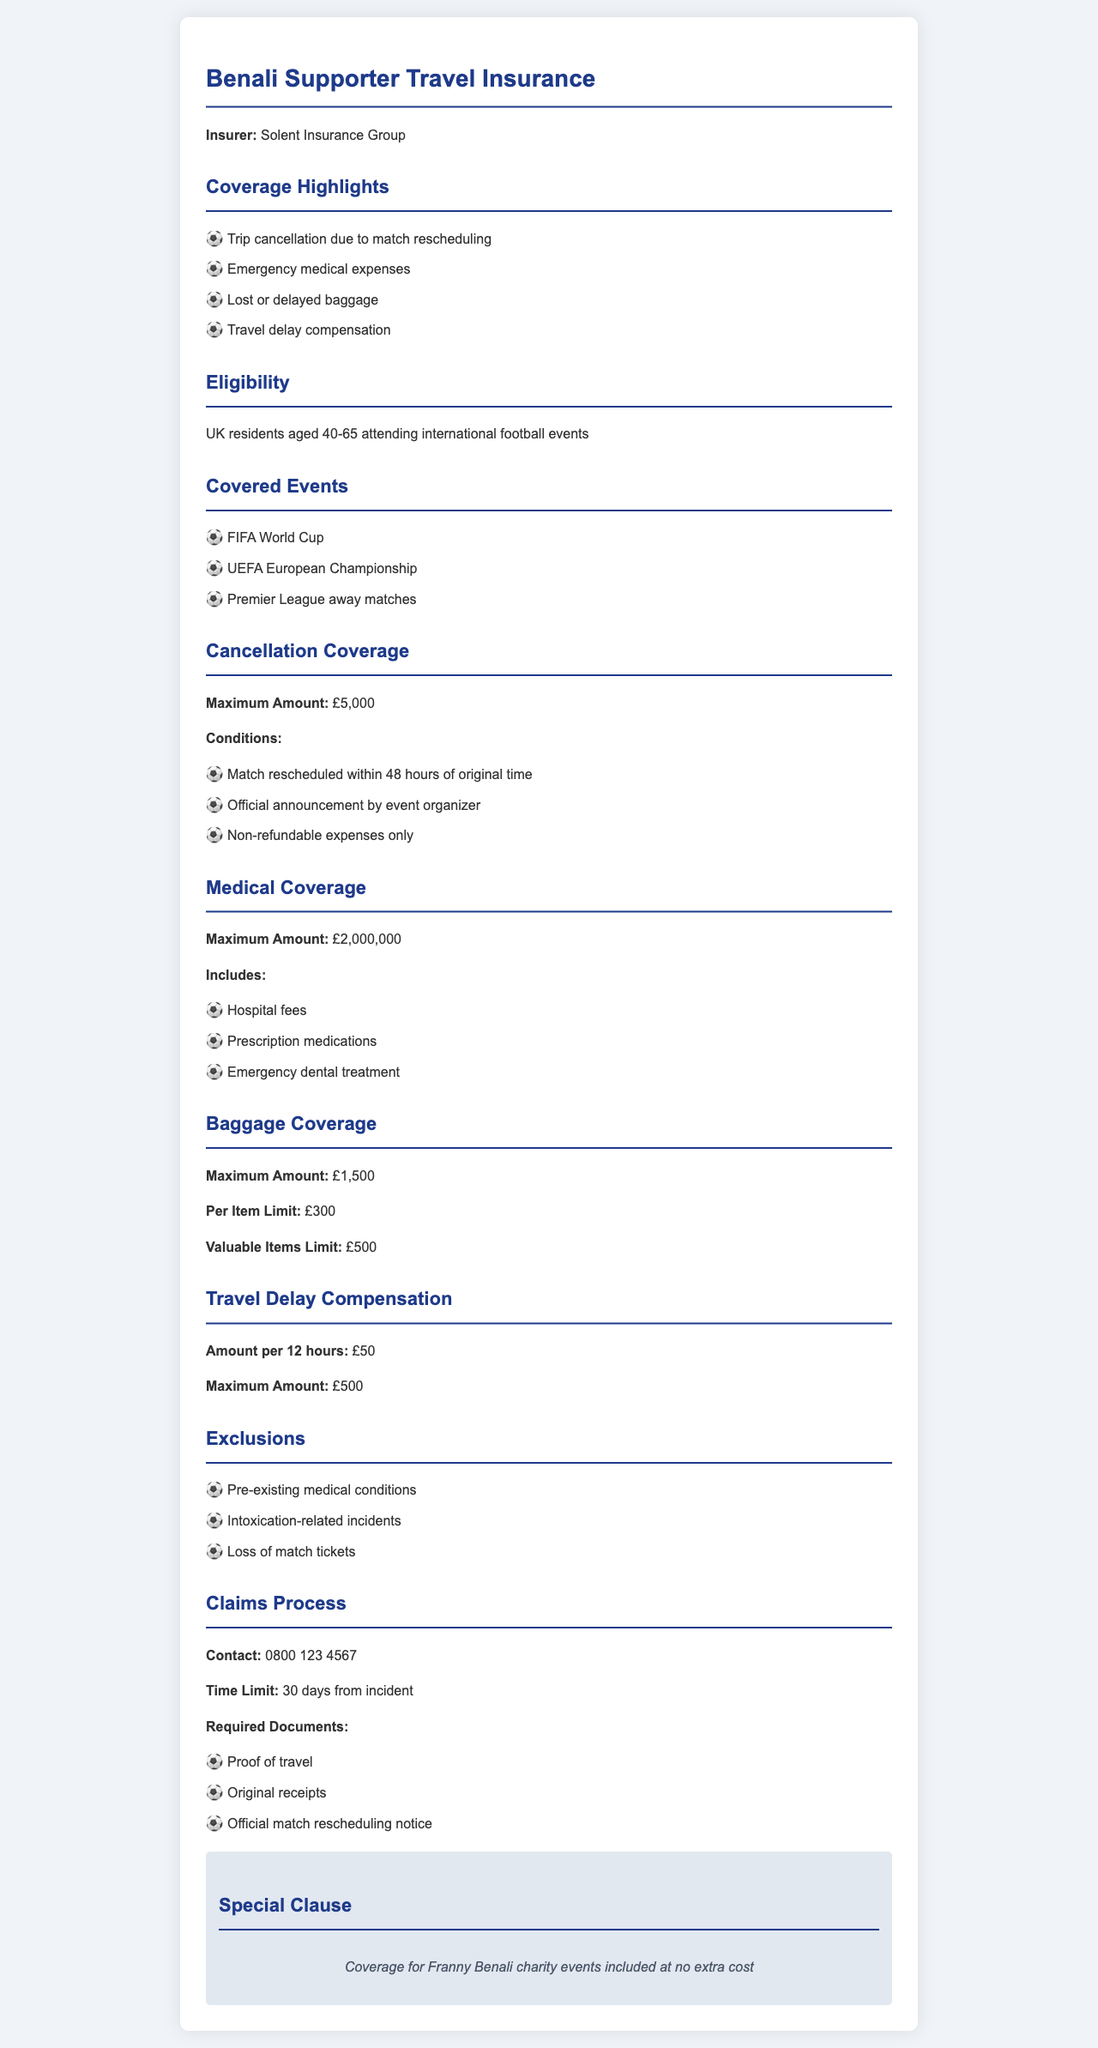What is the insurer's name? The document states that the insurer is Solent Insurance Group.
Answer: Solent Insurance Group What is the maximum amount for trip cancellation coverage? The document specifies that the maximum amount for trip cancellation coverage is £5,000.
Answer: £5,000 What conditions must be met for trip cancellations? The coverage conditions include match rescheduling within 48 hours, an official announcement, and non-refundable expenses only.
Answer: Match rescheduled within 48 hours of original time What is the maximum amount for medical coverage? The document indicates that the maximum amount for medical coverage is £2,000,000.
Answer: £2,000,000 Which international events are covered? The covered events listed in the document include FIFA World Cup and UEFA European Championship among others.
Answer: FIFA World Cup How much is the compensation for travel delay per 12 hours? The document states that the amount per 12 hours for travel delay compensation is £50.
Answer: £50 What is the time limit for submitting a claim? The claims process mentions that the time limit for submitting a claim is 30 days from the incident.
Answer: 30 days What does the special clause mention? The special clause in the document states that coverage for Franny Benali charity events is included at no extra cost.
Answer: Coverage for Franny Benali charity events included at no extra cost What is the maximum amount for baggage coverage? The document specifies that the maximum amount for baggage coverage is £1,500.
Answer: £1,500 